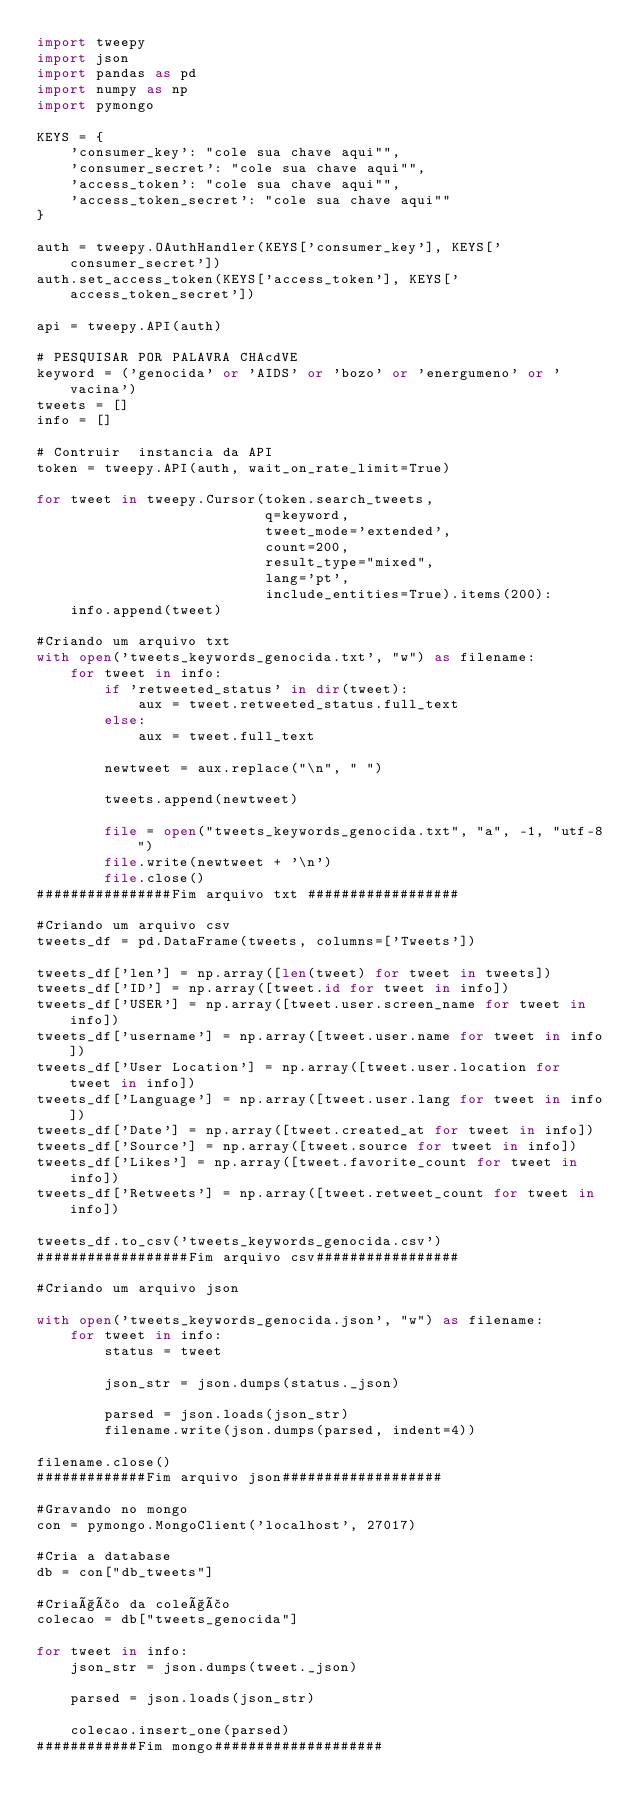Convert code to text. <code><loc_0><loc_0><loc_500><loc_500><_Python_>import tweepy
import json
import pandas as pd
import numpy as np
import pymongo

KEYS = {
    'consumer_key': "cole sua chave aqui"",
    'consumer_secret': "cole sua chave aqui"",
    'access_token': "cole sua chave aqui"",
    'access_token_secret': "cole sua chave aqui""
}

auth = tweepy.OAuthHandler(KEYS['consumer_key'], KEYS['consumer_secret'])
auth.set_access_token(KEYS['access_token'], KEYS['access_token_secret'])

api = tweepy.API(auth)

# PESQUISAR POR PALAVRA CHAcdVE
keyword = ('genocida' or 'AIDS' or 'bozo' or 'energumeno' or 'vacina')
tweets = []
info = []

# Contruir  instancia da API
token = tweepy.API(auth, wait_on_rate_limit=True)

for tweet in tweepy.Cursor(token.search_tweets,
                           q=keyword,
                           tweet_mode='extended',
                           count=200,
                           result_type="mixed",
                           lang='pt',
                           include_entities=True).items(200):
    info.append(tweet)

#Criando um arquivo txt
with open('tweets_keywords_genocida.txt', "w") as filename:
    for tweet in info:
        if 'retweeted_status' in dir(tweet):
            aux = tweet.retweeted_status.full_text
        else:
            aux = tweet.full_text

        newtweet = aux.replace("\n", " ")

        tweets.append(newtweet)

        file = open("tweets_keywords_genocida.txt", "a", -1, "utf-8")
        file.write(newtweet + '\n')
        file.close()
################Fim arquivo txt ##################

#Criando um arquivo csv
tweets_df = pd.DataFrame(tweets, columns=['Tweets'])

tweets_df['len'] = np.array([len(tweet) for tweet in tweets])
tweets_df['ID'] = np.array([tweet.id for tweet in info])
tweets_df['USER'] = np.array([tweet.user.screen_name for tweet in info])
tweets_df['username'] = np.array([tweet.user.name for tweet in info])
tweets_df['User Location'] = np.array([tweet.user.location for tweet in info])
tweets_df['Language'] = np.array([tweet.user.lang for tweet in info])
tweets_df['Date'] = np.array([tweet.created_at for tweet in info])
tweets_df['Source'] = np.array([tweet.source for tweet in info])
tweets_df['Likes'] = np.array([tweet.favorite_count for tweet in info])
tweets_df['Retweets'] = np.array([tweet.retweet_count for tweet in info])

tweets_df.to_csv('tweets_keywords_genocida.csv')
##################Fim arquivo csv#################

#Criando um arquivo json

with open('tweets_keywords_genocida.json', "w") as filename:
    for tweet in info:
        status = tweet

        json_str = json.dumps(status._json)

        parsed = json.loads(json_str)
        filename.write(json.dumps(parsed, indent=4))

filename.close()
#############Fim arquivo json###################

#Gravando no mongo
con = pymongo.MongoClient('localhost', 27017)

#Cria a database
db = con["db_tweets"]

#Criação da coleção
colecao = db["tweets_genocida"]

for tweet in info:
    json_str = json.dumps(tweet._json)

    parsed = json.loads(json_str)

    colecao.insert_one(parsed)
############Fim mongo####################
</code> 